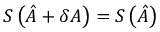<formula> <loc_0><loc_0><loc_500><loc_500>S \left ( \hat { A } + \delta A \right ) = S \left ( \hat { A } \right )</formula> 